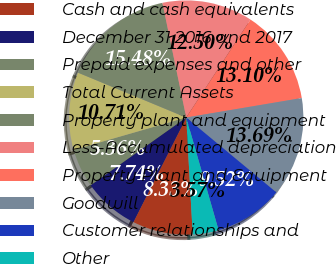Convert chart. <chart><loc_0><loc_0><loc_500><loc_500><pie_chart><fcel>Cash and cash equivalents<fcel>December 31 2016 and 2017<fcel>Prepaid expenses and other<fcel>Total Current Assets<fcel>Property plant and equipment<fcel>Less-Accumulated depreciation<fcel>Property Plant and Equipment<fcel>Goodwill<fcel>Customer relationships and<fcel>Other<nl><fcel>8.33%<fcel>7.74%<fcel>5.36%<fcel>10.71%<fcel>15.48%<fcel>12.5%<fcel>13.1%<fcel>13.69%<fcel>9.52%<fcel>3.57%<nl></chart> 